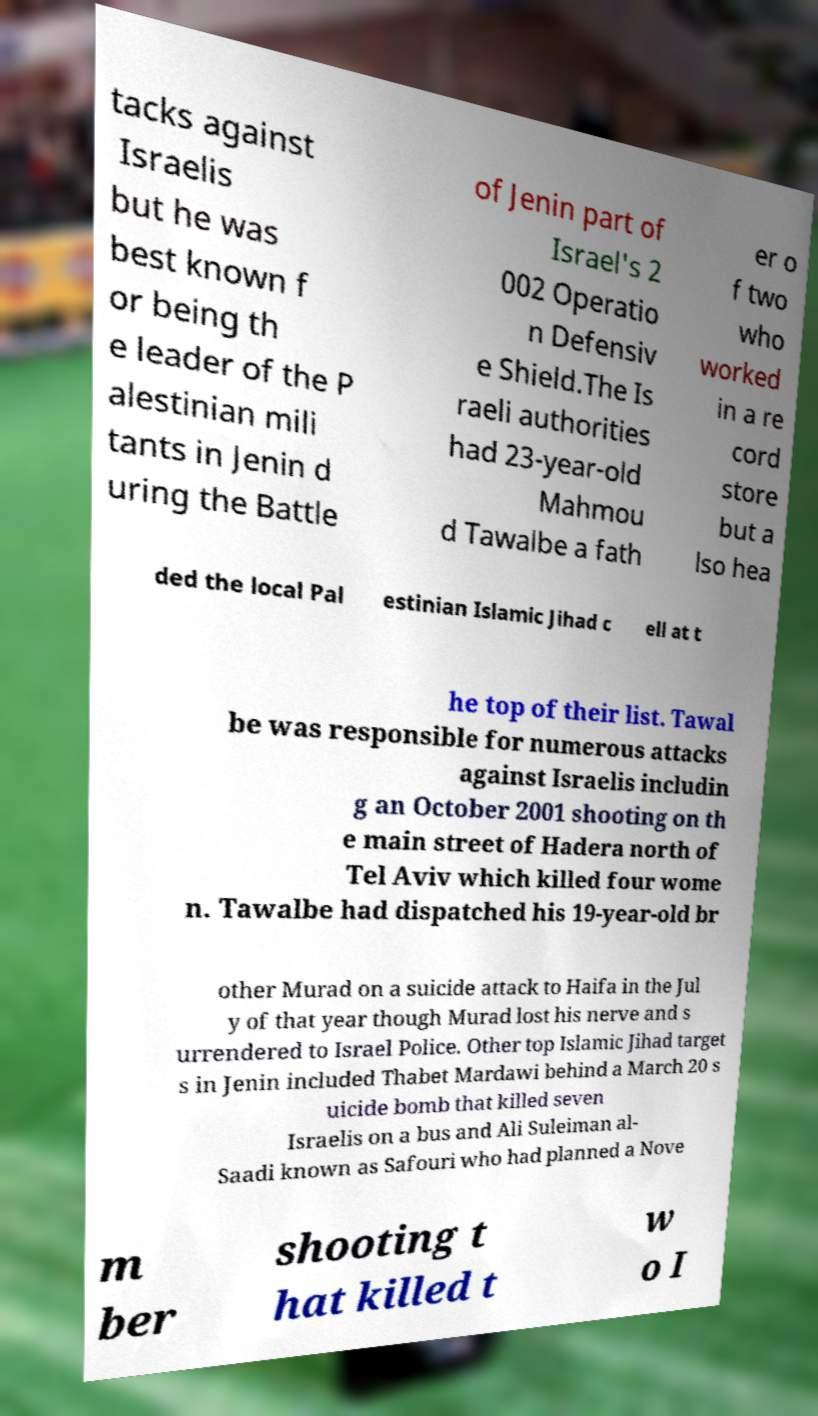For documentation purposes, I need the text within this image transcribed. Could you provide that? tacks against Israelis but he was best known f or being th e leader of the P alestinian mili tants in Jenin d uring the Battle of Jenin part of Israel's 2 002 Operatio n Defensiv e Shield.The Is raeli authorities had 23-year-old Mahmou d Tawalbe a fath er o f two who worked in a re cord store but a lso hea ded the local Pal estinian Islamic Jihad c ell at t he top of their list. Tawal be was responsible for numerous attacks against Israelis includin g an October 2001 shooting on th e main street of Hadera north of Tel Aviv which killed four wome n. Tawalbe had dispatched his 19-year-old br other Murad on a suicide attack to Haifa in the Jul y of that year though Murad lost his nerve and s urrendered to Israel Police. Other top Islamic Jihad target s in Jenin included Thabet Mardawi behind a March 20 s uicide bomb that killed seven Israelis on a bus and Ali Suleiman al- Saadi known as Safouri who had planned a Nove m ber shooting t hat killed t w o I 